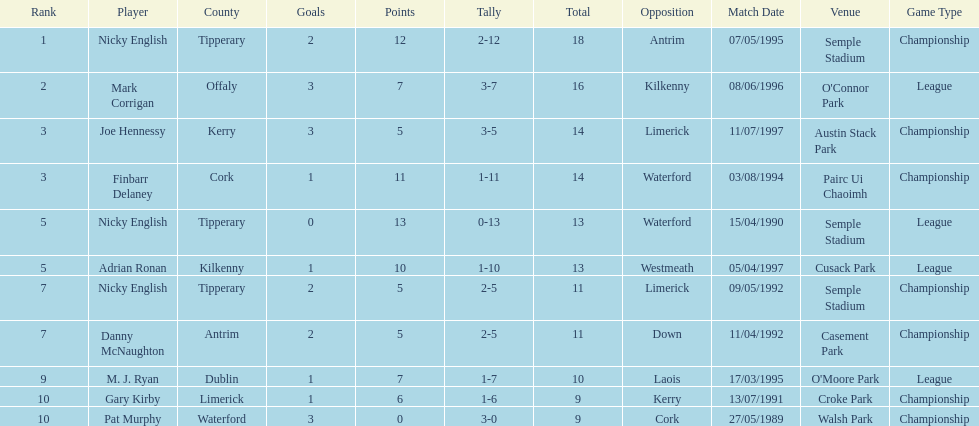What is the first name on the list? Nicky English. 